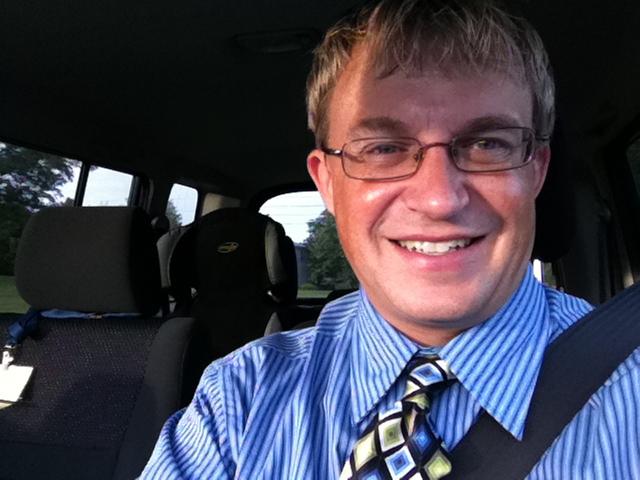Is this man fond of blue?
Answer briefly. Yes. What is the pattern on the man's tie called?
Write a very short answer. Diamond. Is this man crying?
Quick response, please. No. What shape are this man's glasses?
Quick response, please. Rectangular. Does this man have children?
Keep it brief. Yes. 